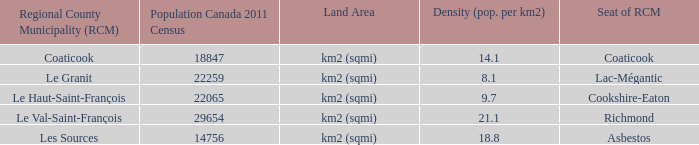What is the RCM that has a density of 9.7? Le Haut-Saint-François. 